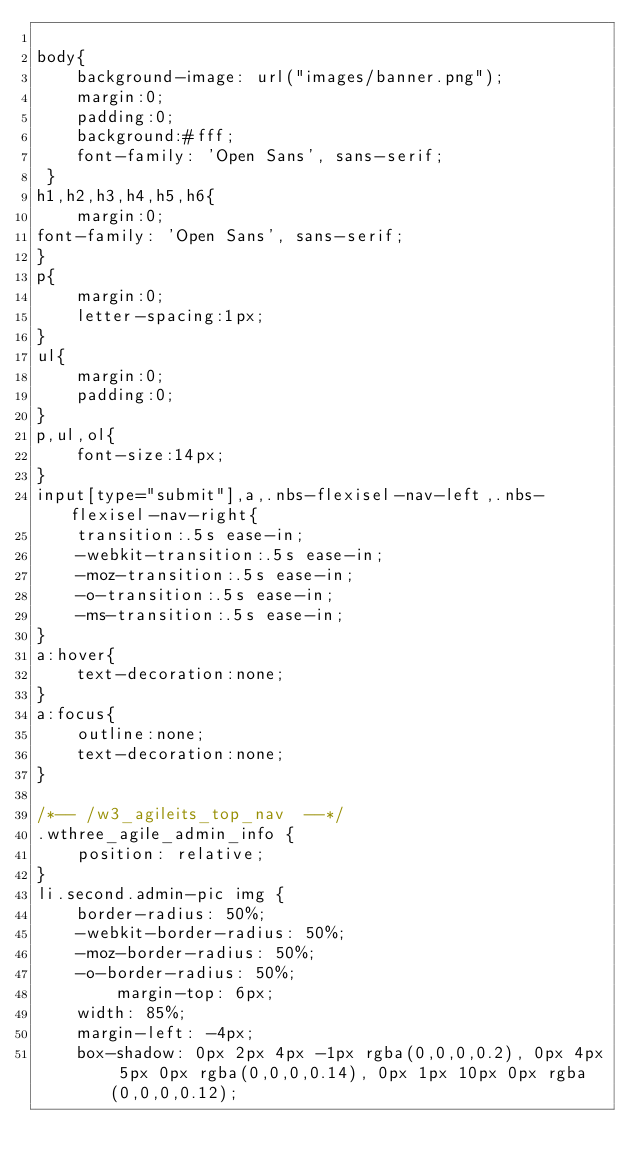Convert code to text. <code><loc_0><loc_0><loc_500><loc_500><_CSS_>
body{
	background-image: url("images/banner.png");
	margin:0;
	padding:0;
	background:#fff;
	font-family: 'Open Sans', sans-serif;
 }
h1,h2,h3,h4,h5,h6{
	margin:0;	
font-family: 'Open Sans', sans-serif;
}	
p{
	margin:0;
	letter-spacing:1px;
}
ul{
	margin:0;
	padding:0;
}
p,ul,ol{
	font-size:14px;
}
input[type="submit"],a,.nbs-flexisel-nav-left,.nbs-flexisel-nav-right{
	transition:.5s ease-in;
	-webkit-transition:.5s ease-in;
	-moz-transition:.5s ease-in;
	-o-transition:.5s ease-in;
	-ms-transition:.5s ease-in;
}
a:hover{
	text-decoration:none;
}
a:focus{
	outline:none;
	text-decoration:none;
}

/*-- /w3_agileits_top_nav  --*/
.wthree_agile_admin_info {
    position: relative;
}
li.second.admin-pic img {
    border-radius: 50%;
    -webkit-border-radius: 50%;
    -moz-border-radius: 50%;
    -o-border-radius: 50%;
	    margin-top: 6px;
    width: 85%;
    margin-left: -4px;
	box-shadow: 0px 2px 4px -1px rgba(0,0,0,0.2), 0px 4px 5px 0px rgba(0,0,0,0.14), 0px 1px 10px 0px rgba(0,0,0,0.12);</code> 